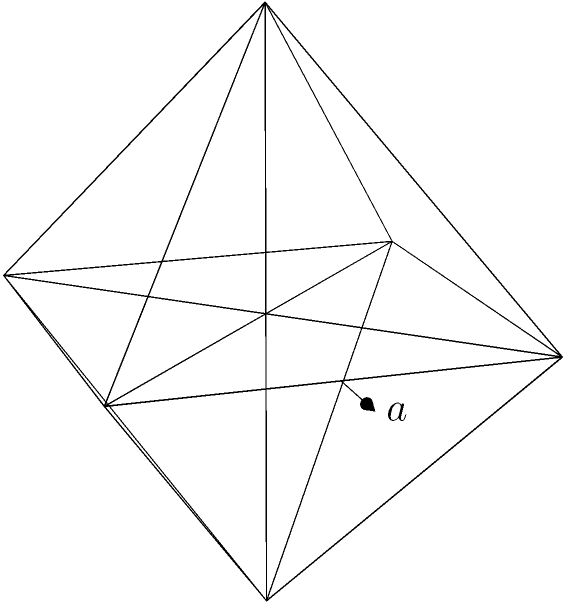As part of a workforce restructuring analysis, you're tasked with optimizing office space. The new office design includes an octahedral sculpture in the lobby, symbolizing the company's eight core values. If the edge length of this regular octahedron is $a$ meters, what is the total surface area of the sculpture? Express your answer in terms of $a^2$. To find the surface area of a regular octahedron, we can follow these steps:

1) A regular octahedron consists of 8 equilateral triangular faces.

2) The surface area will be the sum of the areas of these 8 triangles.

3) For an equilateral triangle with side length $a$, the area is given by:

   $$A_{triangle} = \frac{\sqrt{3}}{4}a^2$$

4) To derive this, recall that the height ($h$) of an equilateral triangle is:

   $$h = \frac{\sqrt{3}}{2}a$$

   And the area of a triangle is $\frac{1}{2} \times base \times height$:

   $$A_{triangle} = \frac{1}{2} \times a \times \frac{\sqrt{3}}{2}a = \frac{\sqrt{3}}{4}a^2$$

5) Since there are 8 identical triangular faces, the total surface area is:

   $$SA_{octahedron} = 8 \times \frac{\sqrt{3}}{4}a^2 = 2\sqrt{3}a^2$$

Therefore, the surface area of the regular octahedron is $2\sqrt{3}a^2$ square meters.
Answer: $2\sqrt{3}a^2$ sq meters 